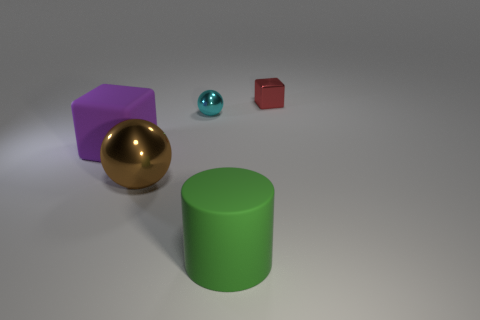Add 5 red cylinders. How many objects exist? 10 Subtract all spheres. How many objects are left? 3 Subtract all large green cylinders. Subtract all large cylinders. How many objects are left? 3 Add 2 cyan metallic objects. How many cyan metallic objects are left? 3 Add 4 small red things. How many small red things exist? 5 Subtract 0 green spheres. How many objects are left? 5 